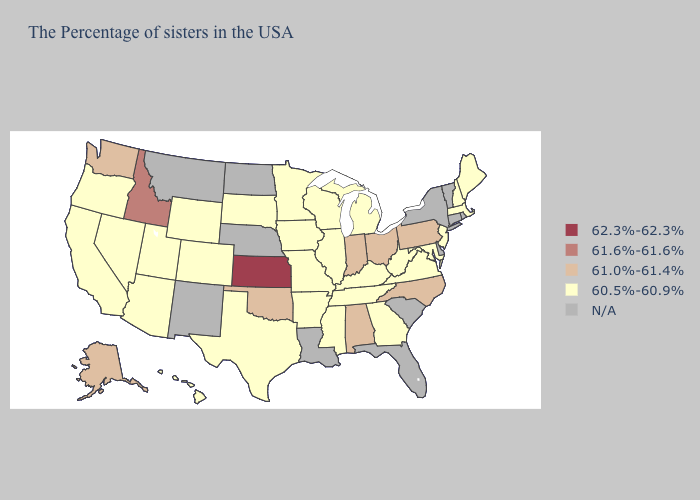What is the highest value in states that border Massachusetts?
Write a very short answer. 60.5%-60.9%. Name the states that have a value in the range 62.3%-62.3%?
Short answer required. Kansas. What is the lowest value in the West?
Keep it brief. 60.5%-60.9%. Which states have the lowest value in the USA?
Answer briefly. Maine, Massachusetts, New Hampshire, New Jersey, Maryland, Virginia, West Virginia, Georgia, Michigan, Kentucky, Tennessee, Wisconsin, Illinois, Mississippi, Missouri, Arkansas, Minnesota, Iowa, Texas, South Dakota, Wyoming, Colorado, Utah, Arizona, Nevada, California, Oregon, Hawaii. Name the states that have a value in the range 61.0%-61.4%?
Give a very brief answer. Pennsylvania, North Carolina, Ohio, Indiana, Alabama, Oklahoma, Washington, Alaska. What is the value of Connecticut?
Answer briefly. N/A. What is the value of Massachusetts?
Concise answer only. 60.5%-60.9%. Is the legend a continuous bar?
Quick response, please. No. Among the states that border Virginia , does North Carolina have the lowest value?
Answer briefly. No. What is the lowest value in the USA?
Short answer required. 60.5%-60.9%. What is the value of Arizona?
Be succinct. 60.5%-60.9%. Among the states that border Virginia , does Kentucky have the lowest value?
Write a very short answer. Yes. Name the states that have a value in the range N/A?
Give a very brief answer. Rhode Island, Vermont, Connecticut, New York, Delaware, South Carolina, Florida, Louisiana, Nebraska, North Dakota, New Mexico, Montana. 